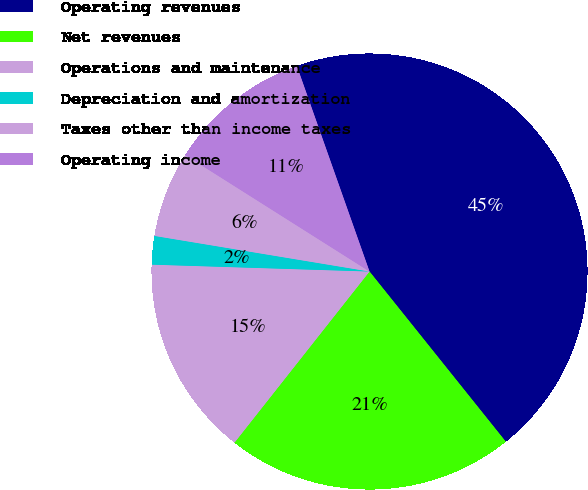Convert chart to OTSL. <chart><loc_0><loc_0><loc_500><loc_500><pie_chart><fcel>Operating revenues<fcel>Net revenues<fcel>Operations and maintenance<fcel>Depreciation and amortization<fcel>Taxes other than income taxes<fcel>Operating income<nl><fcel>44.66%<fcel>21.38%<fcel>14.87%<fcel>2.11%<fcel>6.36%<fcel>10.62%<nl></chart> 